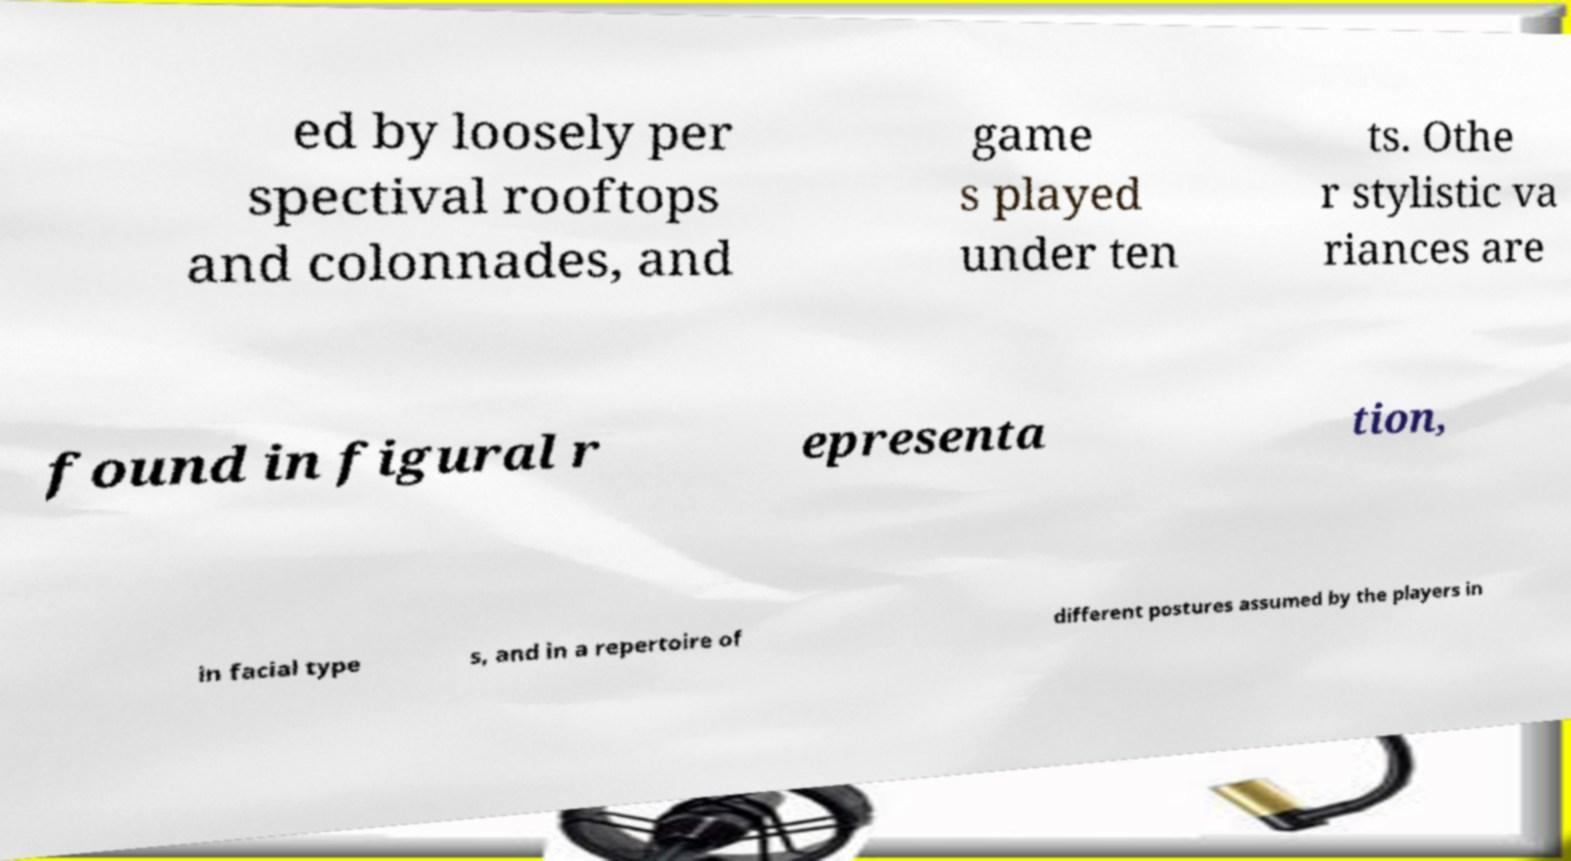Could you assist in decoding the text presented in this image and type it out clearly? ed by loosely per spectival rooftops and colonnades, and game s played under ten ts. Othe r stylistic va riances are found in figural r epresenta tion, in facial type s, and in a repertoire of different postures assumed by the players in 